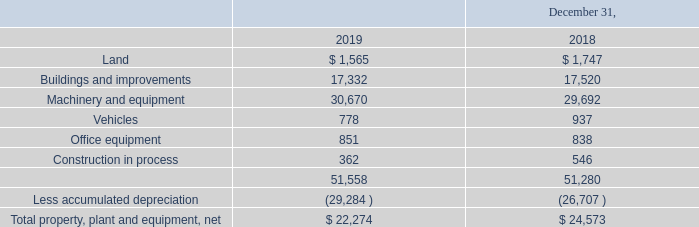Note 4 – Property, Plant and Equipment, net
Property, plant and equipment consisted of the following:
What is the value of buildings and improvements in 2018 and 2019 respectively? 17,520, 17,332. What is the value of machinery and equipment in 2018 and 2019 respectively? 29,692, 30,670. What is the value of vehicles in 2018 and 2019 respectively? 937, 778. What is the average value of vehicles for 2018 and 2019? (778+937)/2
Answer: 857.5. What is the change in the value of land between 2018 and 2019? 1,565-1,747
Answer: -182. Which year has a higher total property, plant and equipment, net value? Compare the value of the total property, plant and equipment, net value between the years
Answer: 2018. 